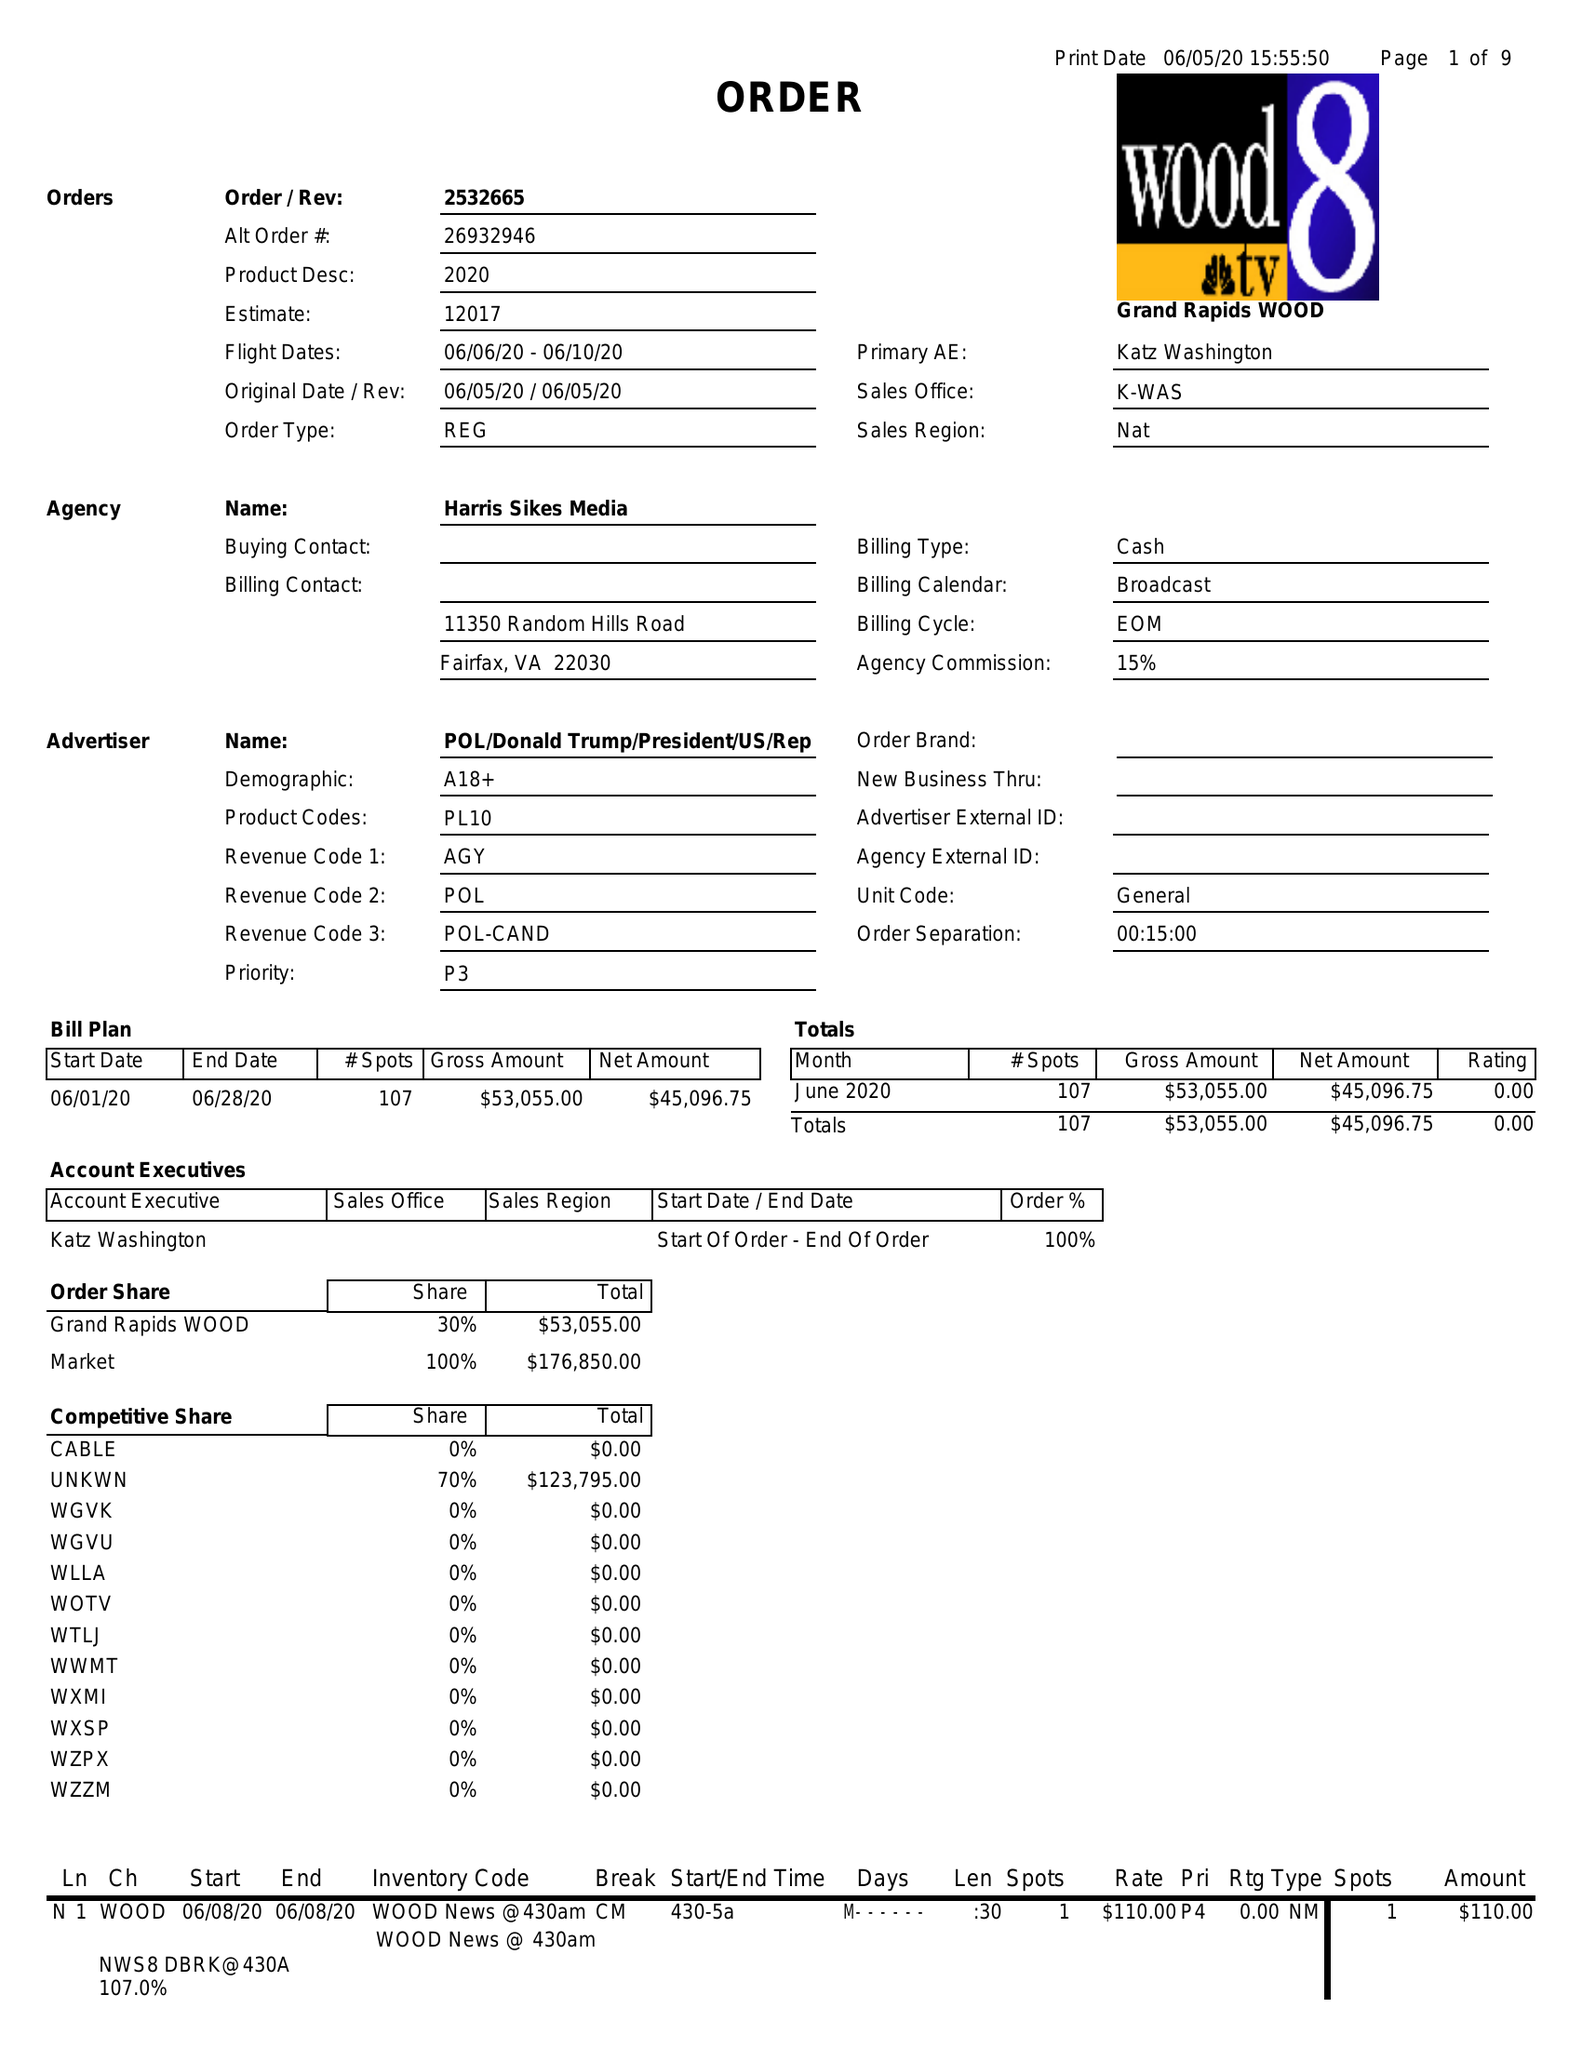What is the value for the contract_num?
Answer the question using a single word or phrase. 2532665 